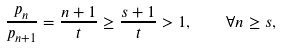<formula> <loc_0><loc_0><loc_500><loc_500>\frac { p _ { n } } { p _ { n + 1 } } = \frac { n + 1 } { t } \geq \frac { s + 1 } { t } > 1 , \quad \forall n \geq s ,</formula> 